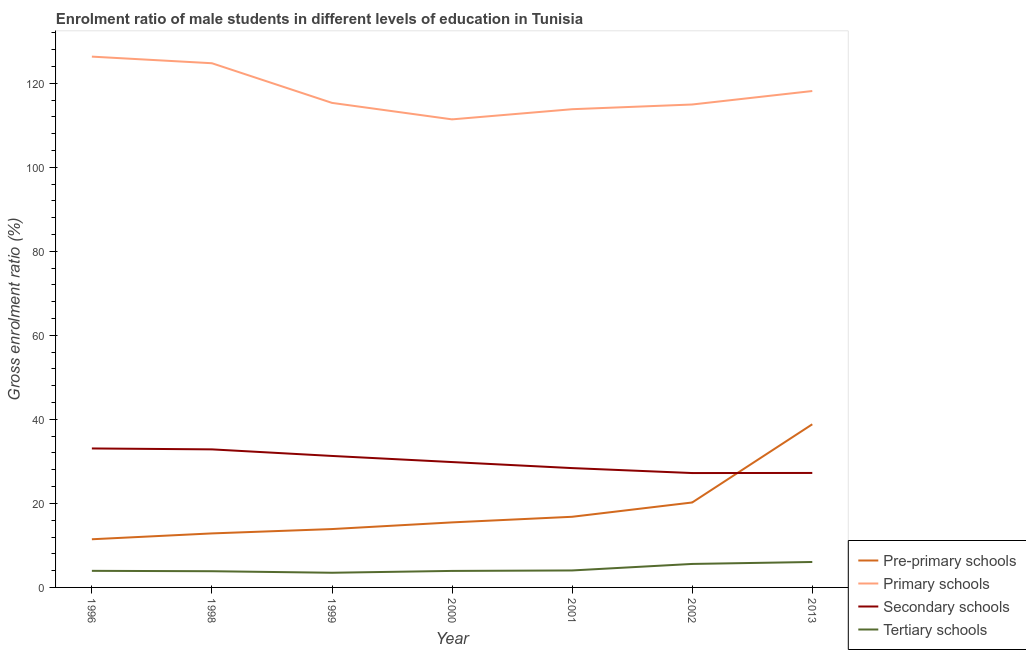How many different coloured lines are there?
Your response must be concise. 4. What is the gross enrolment ratio(female) in primary schools in 1996?
Ensure brevity in your answer.  126.34. Across all years, what is the maximum gross enrolment ratio(female) in secondary schools?
Offer a terse response. 33.08. Across all years, what is the minimum gross enrolment ratio(female) in primary schools?
Your answer should be very brief. 111.41. What is the total gross enrolment ratio(female) in secondary schools in the graph?
Your answer should be very brief. 209.96. What is the difference between the gross enrolment ratio(female) in pre-primary schools in 1996 and that in 1999?
Your response must be concise. -2.43. What is the difference between the gross enrolment ratio(female) in pre-primary schools in 2002 and the gross enrolment ratio(female) in tertiary schools in 1999?
Make the answer very short. 16.73. What is the average gross enrolment ratio(female) in tertiary schools per year?
Your answer should be very brief. 4.42. In the year 1999, what is the difference between the gross enrolment ratio(female) in primary schools and gross enrolment ratio(female) in secondary schools?
Give a very brief answer. 84.04. In how many years, is the gross enrolment ratio(female) in primary schools greater than 48 %?
Offer a terse response. 7. What is the ratio of the gross enrolment ratio(female) in primary schools in 2000 to that in 2002?
Provide a short and direct response. 0.97. Is the gross enrolment ratio(female) in pre-primary schools in 1999 less than that in 2000?
Make the answer very short. Yes. What is the difference between the highest and the second highest gross enrolment ratio(female) in pre-primary schools?
Your response must be concise. 18.61. What is the difference between the highest and the lowest gross enrolment ratio(female) in primary schools?
Ensure brevity in your answer.  14.93. In how many years, is the gross enrolment ratio(female) in primary schools greater than the average gross enrolment ratio(female) in primary schools taken over all years?
Give a very brief answer. 3. Is it the case that in every year, the sum of the gross enrolment ratio(female) in primary schools and gross enrolment ratio(female) in tertiary schools is greater than the sum of gross enrolment ratio(female) in secondary schools and gross enrolment ratio(female) in pre-primary schools?
Offer a terse response. Yes. Is it the case that in every year, the sum of the gross enrolment ratio(female) in pre-primary schools and gross enrolment ratio(female) in primary schools is greater than the gross enrolment ratio(female) in secondary schools?
Your answer should be compact. Yes. Is the gross enrolment ratio(female) in pre-primary schools strictly greater than the gross enrolment ratio(female) in secondary schools over the years?
Ensure brevity in your answer.  No. Where does the legend appear in the graph?
Make the answer very short. Bottom right. How are the legend labels stacked?
Give a very brief answer. Vertical. What is the title of the graph?
Provide a short and direct response. Enrolment ratio of male students in different levels of education in Tunisia. Does "United States" appear as one of the legend labels in the graph?
Make the answer very short. No. What is the label or title of the Y-axis?
Your answer should be compact. Gross enrolment ratio (%). What is the Gross enrolment ratio (%) of Pre-primary schools in 1996?
Provide a short and direct response. 11.47. What is the Gross enrolment ratio (%) of Primary schools in 1996?
Keep it short and to the point. 126.34. What is the Gross enrolment ratio (%) in Secondary schools in 1996?
Ensure brevity in your answer.  33.08. What is the Gross enrolment ratio (%) of Tertiary schools in 1996?
Your answer should be compact. 3.95. What is the Gross enrolment ratio (%) in Pre-primary schools in 1998?
Offer a terse response. 12.86. What is the Gross enrolment ratio (%) of Primary schools in 1998?
Make the answer very short. 124.77. What is the Gross enrolment ratio (%) of Secondary schools in 1998?
Your answer should be very brief. 32.86. What is the Gross enrolment ratio (%) in Tertiary schools in 1998?
Provide a short and direct response. 3.86. What is the Gross enrolment ratio (%) in Pre-primary schools in 1999?
Make the answer very short. 13.89. What is the Gross enrolment ratio (%) in Primary schools in 1999?
Give a very brief answer. 115.33. What is the Gross enrolment ratio (%) of Secondary schools in 1999?
Make the answer very short. 31.3. What is the Gross enrolment ratio (%) in Tertiary schools in 1999?
Your answer should be compact. 3.49. What is the Gross enrolment ratio (%) of Pre-primary schools in 2000?
Your answer should be compact. 15.48. What is the Gross enrolment ratio (%) of Primary schools in 2000?
Provide a succinct answer. 111.41. What is the Gross enrolment ratio (%) in Secondary schools in 2000?
Your answer should be compact. 29.84. What is the Gross enrolment ratio (%) of Tertiary schools in 2000?
Your answer should be compact. 3.93. What is the Gross enrolment ratio (%) in Pre-primary schools in 2001?
Make the answer very short. 16.82. What is the Gross enrolment ratio (%) of Primary schools in 2001?
Give a very brief answer. 113.83. What is the Gross enrolment ratio (%) of Secondary schools in 2001?
Give a very brief answer. 28.4. What is the Gross enrolment ratio (%) in Tertiary schools in 2001?
Your response must be concise. 4.04. What is the Gross enrolment ratio (%) in Pre-primary schools in 2002?
Give a very brief answer. 20.22. What is the Gross enrolment ratio (%) of Primary schools in 2002?
Offer a terse response. 114.95. What is the Gross enrolment ratio (%) of Secondary schools in 2002?
Offer a terse response. 27.23. What is the Gross enrolment ratio (%) in Tertiary schools in 2002?
Offer a terse response. 5.59. What is the Gross enrolment ratio (%) in Pre-primary schools in 2013?
Keep it short and to the point. 38.83. What is the Gross enrolment ratio (%) in Primary schools in 2013?
Provide a short and direct response. 118.16. What is the Gross enrolment ratio (%) in Secondary schools in 2013?
Provide a short and direct response. 27.25. What is the Gross enrolment ratio (%) in Tertiary schools in 2013?
Your answer should be compact. 6.06. Across all years, what is the maximum Gross enrolment ratio (%) in Pre-primary schools?
Give a very brief answer. 38.83. Across all years, what is the maximum Gross enrolment ratio (%) of Primary schools?
Your answer should be very brief. 126.34. Across all years, what is the maximum Gross enrolment ratio (%) of Secondary schools?
Your answer should be very brief. 33.08. Across all years, what is the maximum Gross enrolment ratio (%) in Tertiary schools?
Make the answer very short. 6.06. Across all years, what is the minimum Gross enrolment ratio (%) in Pre-primary schools?
Your answer should be very brief. 11.47. Across all years, what is the minimum Gross enrolment ratio (%) in Primary schools?
Provide a succinct answer. 111.41. Across all years, what is the minimum Gross enrolment ratio (%) of Secondary schools?
Your answer should be very brief. 27.23. Across all years, what is the minimum Gross enrolment ratio (%) in Tertiary schools?
Ensure brevity in your answer.  3.49. What is the total Gross enrolment ratio (%) of Pre-primary schools in the graph?
Keep it short and to the point. 129.57. What is the total Gross enrolment ratio (%) of Primary schools in the graph?
Your response must be concise. 824.8. What is the total Gross enrolment ratio (%) in Secondary schools in the graph?
Your answer should be very brief. 209.96. What is the total Gross enrolment ratio (%) in Tertiary schools in the graph?
Offer a very short reply. 30.92. What is the difference between the Gross enrolment ratio (%) of Pre-primary schools in 1996 and that in 1998?
Give a very brief answer. -1.39. What is the difference between the Gross enrolment ratio (%) of Primary schools in 1996 and that in 1998?
Provide a succinct answer. 1.57. What is the difference between the Gross enrolment ratio (%) of Secondary schools in 1996 and that in 1998?
Ensure brevity in your answer.  0.22. What is the difference between the Gross enrolment ratio (%) in Tertiary schools in 1996 and that in 1998?
Ensure brevity in your answer.  0.09. What is the difference between the Gross enrolment ratio (%) of Pre-primary schools in 1996 and that in 1999?
Provide a short and direct response. -2.43. What is the difference between the Gross enrolment ratio (%) of Primary schools in 1996 and that in 1999?
Your answer should be very brief. 11.01. What is the difference between the Gross enrolment ratio (%) in Secondary schools in 1996 and that in 1999?
Give a very brief answer. 1.78. What is the difference between the Gross enrolment ratio (%) in Tertiary schools in 1996 and that in 1999?
Offer a very short reply. 0.45. What is the difference between the Gross enrolment ratio (%) of Pre-primary schools in 1996 and that in 2000?
Keep it short and to the point. -4.02. What is the difference between the Gross enrolment ratio (%) of Primary schools in 1996 and that in 2000?
Provide a succinct answer. 14.93. What is the difference between the Gross enrolment ratio (%) in Secondary schools in 1996 and that in 2000?
Your answer should be very brief. 3.24. What is the difference between the Gross enrolment ratio (%) of Tertiary schools in 1996 and that in 2000?
Ensure brevity in your answer.  0.02. What is the difference between the Gross enrolment ratio (%) of Pre-primary schools in 1996 and that in 2001?
Offer a terse response. -5.35. What is the difference between the Gross enrolment ratio (%) in Primary schools in 1996 and that in 2001?
Ensure brevity in your answer.  12.51. What is the difference between the Gross enrolment ratio (%) in Secondary schools in 1996 and that in 2001?
Keep it short and to the point. 4.68. What is the difference between the Gross enrolment ratio (%) of Tertiary schools in 1996 and that in 2001?
Offer a very short reply. -0.09. What is the difference between the Gross enrolment ratio (%) in Pre-primary schools in 1996 and that in 2002?
Your answer should be compact. -8.76. What is the difference between the Gross enrolment ratio (%) in Primary schools in 1996 and that in 2002?
Offer a very short reply. 11.39. What is the difference between the Gross enrolment ratio (%) of Secondary schools in 1996 and that in 2002?
Keep it short and to the point. 5.86. What is the difference between the Gross enrolment ratio (%) of Tertiary schools in 1996 and that in 2002?
Offer a very short reply. -1.65. What is the difference between the Gross enrolment ratio (%) of Pre-primary schools in 1996 and that in 2013?
Your answer should be compact. -27.37. What is the difference between the Gross enrolment ratio (%) in Primary schools in 1996 and that in 2013?
Your answer should be very brief. 8.19. What is the difference between the Gross enrolment ratio (%) of Secondary schools in 1996 and that in 2013?
Offer a very short reply. 5.83. What is the difference between the Gross enrolment ratio (%) in Tertiary schools in 1996 and that in 2013?
Make the answer very short. -2.11. What is the difference between the Gross enrolment ratio (%) in Pre-primary schools in 1998 and that in 1999?
Provide a short and direct response. -1.03. What is the difference between the Gross enrolment ratio (%) of Primary schools in 1998 and that in 1999?
Offer a terse response. 9.44. What is the difference between the Gross enrolment ratio (%) in Secondary schools in 1998 and that in 1999?
Give a very brief answer. 1.57. What is the difference between the Gross enrolment ratio (%) in Tertiary schools in 1998 and that in 1999?
Make the answer very short. 0.37. What is the difference between the Gross enrolment ratio (%) of Pre-primary schools in 1998 and that in 2000?
Make the answer very short. -2.62. What is the difference between the Gross enrolment ratio (%) of Primary schools in 1998 and that in 2000?
Provide a succinct answer. 13.36. What is the difference between the Gross enrolment ratio (%) of Secondary schools in 1998 and that in 2000?
Your answer should be very brief. 3.02. What is the difference between the Gross enrolment ratio (%) in Tertiary schools in 1998 and that in 2000?
Ensure brevity in your answer.  -0.07. What is the difference between the Gross enrolment ratio (%) of Pre-primary schools in 1998 and that in 2001?
Offer a very short reply. -3.96. What is the difference between the Gross enrolment ratio (%) of Primary schools in 1998 and that in 2001?
Your response must be concise. 10.94. What is the difference between the Gross enrolment ratio (%) in Secondary schools in 1998 and that in 2001?
Ensure brevity in your answer.  4.46. What is the difference between the Gross enrolment ratio (%) in Tertiary schools in 1998 and that in 2001?
Ensure brevity in your answer.  -0.18. What is the difference between the Gross enrolment ratio (%) in Pre-primary schools in 1998 and that in 2002?
Offer a very short reply. -7.36. What is the difference between the Gross enrolment ratio (%) of Primary schools in 1998 and that in 2002?
Provide a short and direct response. 9.82. What is the difference between the Gross enrolment ratio (%) in Secondary schools in 1998 and that in 2002?
Offer a terse response. 5.64. What is the difference between the Gross enrolment ratio (%) of Tertiary schools in 1998 and that in 2002?
Offer a very short reply. -1.73. What is the difference between the Gross enrolment ratio (%) in Pre-primary schools in 1998 and that in 2013?
Offer a very short reply. -25.98. What is the difference between the Gross enrolment ratio (%) in Primary schools in 1998 and that in 2013?
Make the answer very short. 6.61. What is the difference between the Gross enrolment ratio (%) in Secondary schools in 1998 and that in 2013?
Keep it short and to the point. 5.61. What is the difference between the Gross enrolment ratio (%) of Tertiary schools in 1998 and that in 2013?
Give a very brief answer. -2.2. What is the difference between the Gross enrolment ratio (%) in Pre-primary schools in 1999 and that in 2000?
Your answer should be compact. -1.59. What is the difference between the Gross enrolment ratio (%) in Primary schools in 1999 and that in 2000?
Provide a short and direct response. 3.92. What is the difference between the Gross enrolment ratio (%) in Secondary schools in 1999 and that in 2000?
Provide a succinct answer. 1.46. What is the difference between the Gross enrolment ratio (%) of Tertiary schools in 1999 and that in 2000?
Provide a succinct answer. -0.44. What is the difference between the Gross enrolment ratio (%) in Pre-primary schools in 1999 and that in 2001?
Offer a very short reply. -2.92. What is the difference between the Gross enrolment ratio (%) of Primary schools in 1999 and that in 2001?
Give a very brief answer. 1.5. What is the difference between the Gross enrolment ratio (%) of Secondary schools in 1999 and that in 2001?
Provide a succinct answer. 2.89. What is the difference between the Gross enrolment ratio (%) of Tertiary schools in 1999 and that in 2001?
Keep it short and to the point. -0.55. What is the difference between the Gross enrolment ratio (%) of Pre-primary schools in 1999 and that in 2002?
Ensure brevity in your answer.  -6.33. What is the difference between the Gross enrolment ratio (%) of Primary schools in 1999 and that in 2002?
Your response must be concise. 0.38. What is the difference between the Gross enrolment ratio (%) of Secondary schools in 1999 and that in 2002?
Give a very brief answer. 4.07. What is the difference between the Gross enrolment ratio (%) of Tertiary schools in 1999 and that in 2002?
Your answer should be very brief. -2.1. What is the difference between the Gross enrolment ratio (%) of Pre-primary schools in 1999 and that in 2013?
Make the answer very short. -24.94. What is the difference between the Gross enrolment ratio (%) in Primary schools in 1999 and that in 2013?
Make the answer very short. -2.83. What is the difference between the Gross enrolment ratio (%) in Secondary schools in 1999 and that in 2013?
Your response must be concise. 4.05. What is the difference between the Gross enrolment ratio (%) of Tertiary schools in 1999 and that in 2013?
Provide a short and direct response. -2.57. What is the difference between the Gross enrolment ratio (%) of Pre-primary schools in 2000 and that in 2001?
Make the answer very short. -1.33. What is the difference between the Gross enrolment ratio (%) of Primary schools in 2000 and that in 2001?
Make the answer very short. -2.42. What is the difference between the Gross enrolment ratio (%) of Secondary schools in 2000 and that in 2001?
Offer a terse response. 1.43. What is the difference between the Gross enrolment ratio (%) of Tertiary schools in 2000 and that in 2001?
Keep it short and to the point. -0.11. What is the difference between the Gross enrolment ratio (%) in Pre-primary schools in 2000 and that in 2002?
Ensure brevity in your answer.  -4.74. What is the difference between the Gross enrolment ratio (%) in Primary schools in 2000 and that in 2002?
Ensure brevity in your answer.  -3.54. What is the difference between the Gross enrolment ratio (%) in Secondary schools in 2000 and that in 2002?
Your response must be concise. 2.61. What is the difference between the Gross enrolment ratio (%) of Tertiary schools in 2000 and that in 2002?
Provide a short and direct response. -1.66. What is the difference between the Gross enrolment ratio (%) in Pre-primary schools in 2000 and that in 2013?
Your response must be concise. -23.35. What is the difference between the Gross enrolment ratio (%) in Primary schools in 2000 and that in 2013?
Provide a succinct answer. -6.75. What is the difference between the Gross enrolment ratio (%) of Secondary schools in 2000 and that in 2013?
Give a very brief answer. 2.59. What is the difference between the Gross enrolment ratio (%) in Tertiary schools in 2000 and that in 2013?
Your answer should be compact. -2.13. What is the difference between the Gross enrolment ratio (%) in Pre-primary schools in 2001 and that in 2002?
Your answer should be compact. -3.41. What is the difference between the Gross enrolment ratio (%) in Primary schools in 2001 and that in 2002?
Your answer should be very brief. -1.12. What is the difference between the Gross enrolment ratio (%) in Secondary schools in 2001 and that in 2002?
Make the answer very short. 1.18. What is the difference between the Gross enrolment ratio (%) in Tertiary schools in 2001 and that in 2002?
Give a very brief answer. -1.55. What is the difference between the Gross enrolment ratio (%) in Pre-primary schools in 2001 and that in 2013?
Ensure brevity in your answer.  -22.02. What is the difference between the Gross enrolment ratio (%) of Primary schools in 2001 and that in 2013?
Your answer should be compact. -4.33. What is the difference between the Gross enrolment ratio (%) of Secondary schools in 2001 and that in 2013?
Provide a short and direct response. 1.16. What is the difference between the Gross enrolment ratio (%) of Tertiary schools in 2001 and that in 2013?
Your response must be concise. -2.02. What is the difference between the Gross enrolment ratio (%) in Pre-primary schools in 2002 and that in 2013?
Keep it short and to the point. -18.61. What is the difference between the Gross enrolment ratio (%) in Primary schools in 2002 and that in 2013?
Ensure brevity in your answer.  -3.21. What is the difference between the Gross enrolment ratio (%) in Secondary schools in 2002 and that in 2013?
Make the answer very short. -0.02. What is the difference between the Gross enrolment ratio (%) of Tertiary schools in 2002 and that in 2013?
Offer a very short reply. -0.47. What is the difference between the Gross enrolment ratio (%) in Pre-primary schools in 1996 and the Gross enrolment ratio (%) in Primary schools in 1998?
Provide a short and direct response. -113.31. What is the difference between the Gross enrolment ratio (%) of Pre-primary schools in 1996 and the Gross enrolment ratio (%) of Secondary schools in 1998?
Keep it short and to the point. -21.4. What is the difference between the Gross enrolment ratio (%) in Pre-primary schools in 1996 and the Gross enrolment ratio (%) in Tertiary schools in 1998?
Offer a terse response. 7.61. What is the difference between the Gross enrolment ratio (%) in Primary schools in 1996 and the Gross enrolment ratio (%) in Secondary schools in 1998?
Keep it short and to the point. 93.48. What is the difference between the Gross enrolment ratio (%) of Primary schools in 1996 and the Gross enrolment ratio (%) of Tertiary schools in 1998?
Your answer should be very brief. 122.49. What is the difference between the Gross enrolment ratio (%) in Secondary schools in 1996 and the Gross enrolment ratio (%) in Tertiary schools in 1998?
Keep it short and to the point. 29.22. What is the difference between the Gross enrolment ratio (%) in Pre-primary schools in 1996 and the Gross enrolment ratio (%) in Primary schools in 1999?
Make the answer very short. -103.87. What is the difference between the Gross enrolment ratio (%) in Pre-primary schools in 1996 and the Gross enrolment ratio (%) in Secondary schools in 1999?
Provide a succinct answer. -19.83. What is the difference between the Gross enrolment ratio (%) in Pre-primary schools in 1996 and the Gross enrolment ratio (%) in Tertiary schools in 1999?
Offer a terse response. 7.97. What is the difference between the Gross enrolment ratio (%) of Primary schools in 1996 and the Gross enrolment ratio (%) of Secondary schools in 1999?
Your answer should be compact. 95.05. What is the difference between the Gross enrolment ratio (%) of Primary schools in 1996 and the Gross enrolment ratio (%) of Tertiary schools in 1999?
Your answer should be very brief. 122.85. What is the difference between the Gross enrolment ratio (%) of Secondary schools in 1996 and the Gross enrolment ratio (%) of Tertiary schools in 1999?
Your answer should be compact. 29.59. What is the difference between the Gross enrolment ratio (%) in Pre-primary schools in 1996 and the Gross enrolment ratio (%) in Primary schools in 2000?
Your answer should be very brief. -99.95. What is the difference between the Gross enrolment ratio (%) of Pre-primary schools in 1996 and the Gross enrolment ratio (%) of Secondary schools in 2000?
Provide a short and direct response. -18.37. What is the difference between the Gross enrolment ratio (%) in Pre-primary schools in 1996 and the Gross enrolment ratio (%) in Tertiary schools in 2000?
Ensure brevity in your answer.  7.54. What is the difference between the Gross enrolment ratio (%) in Primary schools in 1996 and the Gross enrolment ratio (%) in Secondary schools in 2000?
Your answer should be very brief. 96.51. What is the difference between the Gross enrolment ratio (%) of Primary schools in 1996 and the Gross enrolment ratio (%) of Tertiary schools in 2000?
Provide a succinct answer. 122.41. What is the difference between the Gross enrolment ratio (%) in Secondary schools in 1996 and the Gross enrolment ratio (%) in Tertiary schools in 2000?
Offer a terse response. 29.15. What is the difference between the Gross enrolment ratio (%) of Pre-primary schools in 1996 and the Gross enrolment ratio (%) of Primary schools in 2001?
Give a very brief answer. -102.36. What is the difference between the Gross enrolment ratio (%) of Pre-primary schools in 1996 and the Gross enrolment ratio (%) of Secondary schools in 2001?
Give a very brief answer. -16.94. What is the difference between the Gross enrolment ratio (%) of Pre-primary schools in 1996 and the Gross enrolment ratio (%) of Tertiary schools in 2001?
Keep it short and to the point. 7.42. What is the difference between the Gross enrolment ratio (%) of Primary schools in 1996 and the Gross enrolment ratio (%) of Secondary schools in 2001?
Provide a succinct answer. 97.94. What is the difference between the Gross enrolment ratio (%) of Primary schools in 1996 and the Gross enrolment ratio (%) of Tertiary schools in 2001?
Give a very brief answer. 122.3. What is the difference between the Gross enrolment ratio (%) of Secondary schools in 1996 and the Gross enrolment ratio (%) of Tertiary schools in 2001?
Offer a very short reply. 29.04. What is the difference between the Gross enrolment ratio (%) of Pre-primary schools in 1996 and the Gross enrolment ratio (%) of Primary schools in 2002?
Your response must be concise. -103.49. What is the difference between the Gross enrolment ratio (%) of Pre-primary schools in 1996 and the Gross enrolment ratio (%) of Secondary schools in 2002?
Keep it short and to the point. -15.76. What is the difference between the Gross enrolment ratio (%) of Pre-primary schools in 1996 and the Gross enrolment ratio (%) of Tertiary schools in 2002?
Offer a terse response. 5.87. What is the difference between the Gross enrolment ratio (%) of Primary schools in 1996 and the Gross enrolment ratio (%) of Secondary schools in 2002?
Provide a short and direct response. 99.12. What is the difference between the Gross enrolment ratio (%) of Primary schools in 1996 and the Gross enrolment ratio (%) of Tertiary schools in 2002?
Offer a very short reply. 120.75. What is the difference between the Gross enrolment ratio (%) in Secondary schools in 1996 and the Gross enrolment ratio (%) in Tertiary schools in 2002?
Offer a terse response. 27.49. What is the difference between the Gross enrolment ratio (%) in Pre-primary schools in 1996 and the Gross enrolment ratio (%) in Primary schools in 2013?
Offer a very short reply. -106.69. What is the difference between the Gross enrolment ratio (%) in Pre-primary schools in 1996 and the Gross enrolment ratio (%) in Secondary schools in 2013?
Keep it short and to the point. -15.78. What is the difference between the Gross enrolment ratio (%) in Pre-primary schools in 1996 and the Gross enrolment ratio (%) in Tertiary schools in 2013?
Provide a short and direct response. 5.41. What is the difference between the Gross enrolment ratio (%) in Primary schools in 1996 and the Gross enrolment ratio (%) in Secondary schools in 2013?
Keep it short and to the point. 99.1. What is the difference between the Gross enrolment ratio (%) in Primary schools in 1996 and the Gross enrolment ratio (%) in Tertiary schools in 2013?
Provide a succinct answer. 120.29. What is the difference between the Gross enrolment ratio (%) of Secondary schools in 1996 and the Gross enrolment ratio (%) of Tertiary schools in 2013?
Give a very brief answer. 27.02. What is the difference between the Gross enrolment ratio (%) in Pre-primary schools in 1998 and the Gross enrolment ratio (%) in Primary schools in 1999?
Provide a short and direct response. -102.47. What is the difference between the Gross enrolment ratio (%) in Pre-primary schools in 1998 and the Gross enrolment ratio (%) in Secondary schools in 1999?
Ensure brevity in your answer.  -18.44. What is the difference between the Gross enrolment ratio (%) in Pre-primary schools in 1998 and the Gross enrolment ratio (%) in Tertiary schools in 1999?
Ensure brevity in your answer.  9.37. What is the difference between the Gross enrolment ratio (%) in Primary schools in 1998 and the Gross enrolment ratio (%) in Secondary schools in 1999?
Ensure brevity in your answer.  93.48. What is the difference between the Gross enrolment ratio (%) in Primary schools in 1998 and the Gross enrolment ratio (%) in Tertiary schools in 1999?
Give a very brief answer. 121.28. What is the difference between the Gross enrolment ratio (%) of Secondary schools in 1998 and the Gross enrolment ratio (%) of Tertiary schools in 1999?
Keep it short and to the point. 29.37. What is the difference between the Gross enrolment ratio (%) of Pre-primary schools in 1998 and the Gross enrolment ratio (%) of Primary schools in 2000?
Give a very brief answer. -98.55. What is the difference between the Gross enrolment ratio (%) of Pre-primary schools in 1998 and the Gross enrolment ratio (%) of Secondary schools in 2000?
Your answer should be compact. -16.98. What is the difference between the Gross enrolment ratio (%) of Pre-primary schools in 1998 and the Gross enrolment ratio (%) of Tertiary schools in 2000?
Your answer should be very brief. 8.93. What is the difference between the Gross enrolment ratio (%) in Primary schools in 1998 and the Gross enrolment ratio (%) in Secondary schools in 2000?
Ensure brevity in your answer.  94.93. What is the difference between the Gross enrolment ratio (%) in Primary schools in 1998 and the Gross enrolment ratio (%) in Tertiary schools in 2000?
Your answer should be compact. 120.84. What is the difference between the Gross enrolment ratio (%) of Secondary schools in 1998 and the Gross enrolment ratio (%) of Tertiary schools in 2000?
Keep it short and to the point. 28.93. What is the difference between the Gross enrolment ratio (%) in Pre-primary schools in 1998 and the Gross enrolment ratio (%) in Primary schools in 2001?
Offer a terse response. -100.97. What is the difference between the Gross enrolment ratio (%) of Pre-primary schools in 1998 and the Gross enrolment ratio (%) of Secondary schools in 2001?
Provide a short and direct response. -15.55. What is the difference between the Gross enrolment ratio (%) in Pre-primary schools in 1998 and the Gross enrolment ratio (%) in Tertiary schools in 2001?
Make the answer very short. 8.82. What is the difference between the Gross enrolment ratio (%) in Primary schools in 1998 and the Gross enrolment ratio (%) in Secondary schools in 2001?
Give a very brief answer. 96.37. What is the difference between the Gross enrolment ratio (%) of Primary schools in 1998 and the Gross enrolment ratio (%) of Tertiary schools in 2001?
Make the answer very short. 120.73. What is the difference between the Gross enrolment ratio (%) in Secondary schools in 1998 and the Gross enrolment ratio (%) in Tertiary schools in 2001?
Offer a very short reply. 28.82. What is the difference between the Gross enrolment ratio (%) of Pre-primary schools in 1998 and the Gross enrolment ratio (%) of Primary schools in 2002?
Your answer should be very brief. -102.09. What is the difference between the Gross enrolment ratio (%) of Pre-primary schools in 1998 and the Gross enrolment ratio (%) of Secondary schools in 2002?
Make the answer very short. -14.37. What is the difference between the Gross enrolment ratio (%) in Pre-primary schools in 1998 and the Gross enrolment ratio (%) in Tertiary schools in 2002?
Make the answer very short. 7.27. What is the difference between the Gross enrolment ratio (%) in Primary schools in 1998 and the Gross enrolment ratio (%) in Secondary schools in 2002?
Offer a terse response. 97.55. What is the difference between the Gross enrolment ratio (%) in Primary schools in 1998 and the Gross enrolment ratio (%) in Tertiary schools in 2002?
Provide a succinct answer. 119.18. What is the difference between the Gross enrolment ratio (%) in Secondary schools in 1998 and the Gross enrolment ratio (%) in Tertiary schools in 2002?
Your response must be concise. 27.27. What is the difference between the Gross enrolment ratio (%) of Pre-primary schools in 1998 and the Gross enrolment ratio (%) of Primary schools in 2013?
Provide a short and direct response. -105.3. What is the difference between the Gross enrolment ratio (%) of Pre-primary schools in 1998 and the Gross enrolment ratio (%) of Secondary schools in 2013?
Provide a short and direct response. -14.39. What is the difference between the Gross enrolment ratio (%) of Pre-primary schools in 1998 and the Gross enrolment ratio (%) of Tertiary schools in 2013?
Offer a very short reply. 6.8. What is the difference between the Gross enrolment ratio (%) of Primary schools in 1998 and the Gross enrolment ratio (%) of Secondary schools in 2013?
Your answer should be compact. 97.52. What is the difference between the Gross enrolment ratio (%) in Primary schools in 1998 and the Gross enrolment ratio (%) in Tertiary schools in 2013?
Your response must be concise. 118.71. What is the difference between the Gross enrolment ratio (%) of Secondary schools in 1998 and the Gross enrolment ratio (%) of Tertiary schools in 2013?
Ensure brevity in your answer.  26.8. What is the difference between the Gross enrolment ratio (%) of Pre-primary schools in 1999 and the Gross enrolment ratio (%) of Primary schools in 2000?
Provide a short and direct response. -97.52. What is the difference between the Gross enrolment ratio (%) in Pre-primary schools in 1999 and the Gross enrolment ratio (%) in Secondary schools in 2000?
Provide a succinct answer. -15.95. What is the difference between the Gross enrolment ratio (%) in Pre-primary schools in 1999 and the Gross enrolment ratio (%) in Tertiary schools in 2000?
Offer a terse response. 9.96. What is the difference between the Gross enrolment ratio (%) in Primary schools in 1999 and the Gross enrolment ratio (%) in Secondary schools in 2000?
Keep it short and to the point. 85.49. What is the difference between the Gross enrolment ratio (%) in Primary schools in 1999 and the Gross enrolment ratio (%) in Tertiary schools in 2000?
Offer a very short reply. 111.4. What is the difference between the Gross enrolment ratio (%) in Secondary schools in 1999 and the Gross enrolment ratio (%) in Tertiary schools in 2000?
Ensure brevity in your answer.  27.37. What is the difference between the Gross enrolment ratio (%) in Pre-primary schools in 1999 and the Gross enrolment ratio (%) in Primary schools in 2001?
Ensure brevity in your answer.  -99.94. What is the difference between the Gross enrolment ratio (%) of Pre-primary schools in 1999 and the Gross enrolment ratio (%) of Secondary schools in 2001?
Ensure brevity in your answer.  -14.51. What is the difference between the Gross enrolment ratio (%) in Pre-primary schools in 1999 and the Gross enrolment ratio (%) in Tertiary schools in 2001?
Your answer should be very brief. 9.85. What is the difference between the Gross enrolment ratio (%) of Primary schools in 1999 and the Gross enrolment ratio (%) of Secondary schools in 2001?
Ensure brevity in your answer.  86.93. What is the difference between the Gross enrolment ratio (%) of Primary schools in 1999 and the Gross enrolment ratio (%) of Tertiary schools in 2001?
Provide a short and direct response. 111.29. What is the difference between the Gross enrolment ratio (%) in Secondary schools in 1999 and the Gross enrolment ratio (%) in Tertiary schools in 2001?
Keep it short and to the point. 27.26. What is the difference between the Gross enrolment ratio (%) in Pre-primary schools in 1999 and the Gross enrolment ratio (%) in Primary schools in 2002?
Keep it short and to the point. -101.06. What is the difference between the Gross enrolment ratio (%) in Pre-primary schools in 1999 and the Gross enrolment ratio (%) in Secondary schools in 2002?
Offer a terse response. -13.33. What is the difference between the Gross enrolment ratio (%) of Pre-primary schools in 1999 and the Gross enrolment ratio (%) of Tertiary schools in 2002?
Your answer should be very brief. 8.3. What is the difference between the Gross enrolment ratio (%) of Primary schools in 1999 and the Gross enrolment ratio (%) of Secondary schools in 2002?
Make the answer very short. 88.11. What is the difference between the Gross enrolment ratio (%) in Primary schools in 1999 and the Gross enrolment ratio (%) in Tertiary schools in 2002?
Provide a succinct answer. 109.74. What is the difference between the Gross enrolment ratio (%) of Secondary schools in 1999 and the Gross enrolment ratio (%) of Tertiary schools in 2002?
Provide a short and direct response. 25.7. What is the difference between the Gross enrolment ratio (%) in Pre-primary schools in 1999 and the Gross enrolment ratio (%) in Primary schools in 2013?
Give a very brief answer. -104.27. What is the difference between the Gross enrolment ratio (%) of Pre-primary schools in 1999 and the Gross enrolment ratio (%) of Secondary schools in 2013?
Provide a short and direct response. -13.36. What is the difference between the Gross enrolment ratio (%) of Pre-primary schools in 1999 and the Gross enrolment ratio (%) of Tertiary schools in 2013?
Your response must be concise. 7.84. What is the difference between the Gross enrolment ratio (%) of Primary schools in 1999 and the Gross enrolment ratio (%) of Secondary schools in 2013?
Keep it short and to the point. 88.08. What is the difference between the Gross enrolment ratio (%) in Primary schools in 1999 and the Gross enrolment ratio (%) in Tertiary schools in 2013?
Offer a terse response. 109.28. What is the difference between the Gross enrolment ratio (%) of Secondary schools in 1999 and the Gross enrolment ratio (%) of Tertiary schools in 2013?
Offer a very short reply. 25.24. What is the difference between the Gross enrolment ratio (%) of Pre-primary schools in 2000 and the Gross enrolment ratio (%) of Primary schools in 2001?
Your answer should be very brief. -98.35. What is the difference between the Gross enrolment ratio (%) in Pre-primary schools in 2000 and the Gross enrolment ratio (%) in Secondary schools in 2001?
Offer a terse response. -12.92. What is the difference between the Gross enrolment ratio (%) of Pre-primary schools in 2000 and the Gross enrolment ratio (%) of Tertiary schools in 2001?
Offer a very short reply. 11.44. What is the difference between the Gross enrolment ratio (%) of Primary schools in 2000 and the Gross enrolment ratio (%) of Secondary schools in 2001?
Ensure brevity in your answer.  83.01. What is the difference between the Gross enrolment ratio (%) of Primary schools in 2000 and the Gross enrolment ratio (%) of Tertiary schools in 2001?
Provide a succinct answer. 107.37. What is the difference between the Gross enrolment ratio (%) of Secondary schools in 2000 and the Gross enrolment ratio (%) of Tertiary schools in 2001?
Your response must be concise. 25.8. What is the difference between the Gross enrolment ratio (%) in Pre-primary schools in 2000 and the Gross enrolment ratio (%) in Primary schools in 2002?
Make the answer very short. -99.47. What is the difference between the Gross enrolment ratio (%) of Pre-primary schools in 2000 and the Gross enrolment ratio (%) of Secondary schools in 2002?
Your answer should be compact. -11.74. What is the difference between the Gross enrolment ratio (%) in Pre-primary schools in 2000 and the Gross enrolment ratio (%) in Tertiary schools in 2002?
Give a very brief answer. 9.89. What is the difference between the Gross enrolment ratio (%) of Primary schools in 2000 and the Gross enrolment ratio (%) of Secondary schools in 2002?
Your response must be concise. 84.19. What is the difference between the Gross enrolment ratio (%) in Primary schools in 2000 and the Gross enrolment ratio (%) in Tertiary schools in 2002?
Your answer should be compact. 105.82. What is the difference between the Gross enrolment ratio (%) of Secondary schools in 2000 and the Gross enrolment ratio (%) of Tertiary schools in 2002?
Offer a very short reply. 24.25. What is the difference between the Gross enrolment ratio (%) of Pre-primary schools in 2000 and the Gross enrolment ratio (%) of Primary schools in 2013?
Ensure brevity in your answer.  -102.68. What is the difference between the Gross enrolment ratio (%) of Pre-primary schools in 2000 and the Gross enrolment ratio (%) of Secondary schools in 2013?
Provide a succinct answer. -11.77. What is the difference between the Gross enrolment ratio (%) of Pre-primary schools in 2000 and the Gross enrolment ratio (%) of Tertiary schools in 2013?
Offer a very short reply. 9.42. What is the difference between the Gross enrolment ratio (%) in Primary schools in 2000 and the Gross enrolment ratio (%) in Secondary schools in 2013?
Ensure brevity in your answer.  84.16. What is the difference between the Gross enrolment ratio (%) of Primary schools in 2000 and the Gross enrolment ratio (%) of Tertiary schools in 2013?
Ensure brevity in your answer.  105.35. What is the difference between the Gross enrolment ratio (%) in Secondary schools in 2000 and the Gross enrolment ratio (%) in Tertiary schools in 2013?
Give a very brief answer. 23.78. What is the difference between the Gross enrolment ratio (%) in Pre-primary schools in 2001 and the Gross enrolment ratio (%) in Primary schools in 2002?
Give a very brief answer. -98.14. What is the difference between the Gross enrolment ratio (%) in Pre-primary schools in 2001 and the Gross enrolment ratio (%) in Secondary schools in 2002?
Offer a very short reply. -10.41. What is the difference between the Gross enrolment ratio (%) of Pre-primary schools in 2001 and the Gross enrolment ratio (%) of Tertiary schools in 2002?
Ensure brevity in your answer.  11.22. What is the difference between the Gross enrolment ratio (%) of Primary schools in 2001 and the Gross enrolment ratio (%) of Secondary schools in 2002?
Make the answer very short. 86.6. What is the difference between the Gross enrolment ratio (%) of Primary schools in 2001 and the Gross enrolment ratio (%) of Tertiary schools in 2002?
Your answer should be very brief. 108.24. What is the difference between the Gross enrolment ratio (%) in Secondary schools in 2001 and the Gross enrolment ratio (%) in Tertiary schools in 2002?
Ensure brevity in your answer.  22.81. What is the difference between the Gross enrolment ratio (%) in Pre-primary schools in 2001 and the Gross enrolment ratio (%) in Primary schools in 2013?
Make the answer very short. -101.34. What is the difference between the Gross enrolment ratio (%) in Pre-primary schools in 2001 and the Gross enrolment ratio (%) in Secondary schools in 2013?
Provide a succinct answer. -10.43. What is the difference between the Gross enrolment ratio (%) in Pre-primary schools in 2001 and the Gross enrolment ratio (%) in Tertiary schools in 2013?
Offer a very short reply. 10.76. What is the difference between the Gross enrolment ratio (%) of Primary schools in 2001 and the Gross enrolment ratio (%) of Secondary schools in 2013?
Give a very brief answer. 86.58. What is the difference between the Gross enrolment ratio (%) in Primary schools in 2001 and the Gross enrolment ratio (%) in Tertiary schools in 2013?
Your answer should be compact. 107.77. What is the difference between the Gross enrolment ratio (%) in Secondary schools in 2001 and the Gross enrolment ratio (%) in Tertiary schools in 2013?
Give a very brief answer. 22.35. What is the difference between the Gross enrolment ratio (%) of Pre-primary schools in 2002 and the Gross enrolment ratio (%) of Primary schools in 2013?
Ensure brevity in your answer.  -97.94. What is the difference between the Gross enrolment ratio (%) in Pre-primary schools in 2002 and the Gross enrolment ratio (%) in Secondary schools in 2013?
Provide a short and direct response. -7.03. What is the difference between the Gross enrolment ratio (%) in Pre-primary schools in 2002 and the Gross enrolment ratio (%) in Tertiary schools in 2013?
Keep it short and to the point. 14.16. What is the difference between the Gross enrolment ratio (%) in Primary schools in 2002 and the Gross enrolment ratio (%) in Secondary schools in 2013?
Make the answer very short. 87.7. What is the difference between the Gross enrolment ratio (%) in Primary schools in 2002 and the Gross enrolment ratio (%) in Tertiary schools in 2013?
Your response must be concise. 108.89. What is the difference between the Gross enrolment ratio (%) of Secondary schools in 2002 and the Gross enrolment ratio (%) of Tertiary schools in 2013?
Keep it short and to the point. 21.17. What is the average Gross enrolment ratio (%) in Pre-primary schools per year?
Make the answer very short. 18.51. What is the average Gross enrolment ratio (%) of Primary schools per year?
Provide a succinct answer. 117.83. What is the average Gross enrolment ratio (%) in Secondary schools per year?
Provide a succinct answer. 29.99. What is the average Gross enrolment ratio (%) in Tertiary schools per year?
Ensure brevity in your answer.  4.42. In the year 1996, what is the difference between the Gross enrolment ratio (%) in Pre-primary schools and Gross enrolment ratio (%) in Primary schools?
Offer a terse response. -114.88. In the year 1996, what is the difference between the Gross enrolment ratio (%) in Pre-primary schools and Gross enrolment ratio (%) in Secondary schools?
Offer a terse response. -21.61. In the year 1996, what is the difference between the Gross enrolment ratio (%) of Pre-primary schools and Gross enrolment ratio (%) of Tertiary schools?
Provide a succinct answer. 7.52. In the year 1996, what is the difference between the Gross enrolment ratio (%) in Primary schools and Gross enrolment ratio (%) in Secondary schools?
Keep it short and to the point. 93.26. In the year 1996, what is the difference between the Gross enrolment ratio (%) in Primary schools and Gross enrolment ratio (%) in Tertiary schools?
Make the answer very short. 122.4. In the year 1996, what is the difference between the Gross enrolment ratio (%) of Secondary schools and Gross enrolment ratio (%) of Tertiary schools?
Ensure brevity in your answer.  29.13. In the year 1998, what is the difference between the Gross enrolment ratio (%) in Pre-primary schools and Gross enrolment ratio (%) in Primary schools?
Offer a terse response. -111.91. In the year 1998, what is the difference between the Gross enrolment ratio (%) in Pre-primary schools and Gross enrolment ratio (%) in Secondary schools?
Offer a terse response. -20. In the year 1998, what is the difference between the Gross enrolment ratio (%) in Pre-primary schools and Gross enrolment ratio (%) in Tertiary schools?
Offer a very short reply. 9. In the year 1998, what is the difference between the Gross enrolment ratio (%) of Primary schools and Gross enrolment ratio (%) of Secondary schools?
Offer a very short reply. 91.91. In the year 1998, what is the difference between the Gross enrolment ratio (%) in Primary schools and Gross enrolment ratio (%) in Tertiary schools?
Ensure brevity in your answer.  120.91. In the year 1998, what is the difference between the Gross enrolment ratio (%) of Secondary schools and Gross enrolment ratio (%) of Tertiary schools?
Ensure brevity in your answer.  29. In the year 1999, what is the difference between the Gross enrolment ratio (%) in Pre-primary schools and Gross enrolment ratio (%) in Primary schools?
Your response must be concise. -101.44. In the year 1999, what is the difference between the Gross enrolment ratio (%) of Pre-primary schools and Gross enrolment ratio (%) of Secondary schools?
Provide a succinct answer. -17.4. In the year 1999, what is the difference between the Gross enrolment ratio (%) in Pre-primary schools and Gross enrolment ratio (%) in Tertiary schools?
Offer a very short reply. 10.4. In the year 1999, what is the difference between the Gross enrolment ratio (%) of Primary schools and Gross enrolment ratio (%) of Secondary schools?
Provide a succinct answer. 84.04. In the year 1999, what is the difference between the Gross enrolment ratio (%) of Primary schools and Gross enrolment ratio (%) of Tertiary schools?
Your response must be concise. 111.84. In the year 1999, what is the difference between the Gross enrolment ratio (%) of Secondary schools and Gross enrolment ratio (%) of Tertiary schools?
Keep it short and to the point. 27.8. In the year 2000, what is the difference between the Gross enrolment ratio (%) of Pre-primary schools and Gross enrolment ratio (%) of Primary schools?
Make the answer very short. -95.93. In the year 2000, what is the difference between the Gross enrolment ratio (%) of Pre-primary schools and Gross enrolment ratio (%) of Secondary schools?
Your answer should be compact. -14.36. In the year 2000, what is the difference between the Gross enrolment ratio (%) of Pre-primary schools and Gross enrolment ratio (%) of Tertiary schools?
Provide a short and direct response. 11.55. In the year 2000, what is the difference between the Gross enrolment ratio (%) in Primary schools and Gross enrolment ratio (%) in Secondary schools?
Your answer should be compact. 81.57. In the year 2000, what is the difference between the Gross enrolment ratio (%) in Primary schools and Gross enrolment ratio (%) in Tertiary schools?
Keep it short and to the point. 107.48. In the year 2000, what is the difference between the Gross enrolment ratio (%) of Secondary schools and Gross enrolment ratio (%) of Tertiary schools?
Give a very brief answer. 25.91. In the year 2001, what is the difference between the Gross enrolment ratio (%) of Pre-primary schools and Gross enrolment ratio (%) of Primary schools?
Your answer should be very brief. -97.01. In the year 2001, what is the difference between the Gross enrolment ratio (%) in Pre-primary schools and Gross enrolment ratio (%) in Secondary schools?
Give a very brief answer. -11.59. In the year 2001, what is the difference between the Gross enrolment ratio (%) in Pre-primary schools and Gross enrolment ratio (%) in Tertiary schools?
Your response must be concise. 12.78. In the year 2001, what is the difference between the Gross enrolment ratio (%) in Primary schools and Gross enrolment ratio (%) in Secondary schools?
Provide a succinct answer. 85.42. In the year 2001, what is the difference between the Gross enrolment ratio (%) in Primary schools and Gross enrolment ratio (%) in Tertiary schools?
Your answer should be very brief. 109.79. In the year 2001, what is the difference between the Gross enrolment ratio (%) of Secondary schools and Gross enrolment ratio (%) of Tertiary schools?
Your answer should be very brief. 24.36. In the year 2002, what is the difference between the Gross enrolment ratio (%) in Pre-primary schools and Gross enrolment ratio (%) in Primary schools?
Provide a short and direct response. -94.73. In the year 2002, what is the difference between the Gross enrolment ratio (%) in Pre-primary schools and Gross enrolment ratio (%) in Secondary schools?
Your answer should be very brief. -7. In the year 2002, what is the difference between the Gross enrolment ratio (%) in Pre-primary schools and Gross enrolment ratio (%) in Tertiary schools?
Offer a terse response. 14.63. In the year 2002, what is the difference between the Gross enrolment ratio (%) in Primary schools and Gross enrolment ratio (%) in Secondary schools?
Make the answer very short. 87.73. In the year 2002, what is the difference between the Gross enrolment ratio (%) of Primary schools and Gross enrolment ratio (%) of Tertiary schools?
Offer a very short reply. 109.36. In the year 2002, what is the difference between the Gross enrolment ratio (%) of Secondary schools and Gross enrolment ratio (%) of Tertiary schools?
Ensure brevity in your answer.  21.63. In the year 2013, what is the difference between the Gross enrolment ratio (%) of Pre-primary schools and Gross enrolment ratio (%) of Primary schools?
Your answer should be compact. -79.32. In the year 2013, what is the difference between the Gross enrolment ratio (%) of Pre-primary schools and Gross enrolment ratio (%) of Secondary schools?
Provide a short and direct response. 11.59. In the year 2013, what is the difference between the Gross enrolment ratio (%) of Pre-primary schools and Gross enrolment ratio (%) of Tertiary schools?
Your response must be concise. 32.78. In the year 2013, what is the difference between the Gross enrolment ratio (%) in Primary schools and Gross enrolment ratio (%) in Secondary schools?
Your answer should be compact. 90.91. In the year 2013, what is the difference between the Gross enrolment ratio (%) in Primary schools and Gross enrolment ratio (%) in Tertiary schools?
Offer a very short reply. 112.1. In the year 2013, what is the difference between the Gross enrolment ratio (%) in Secondary schools and Gross enrolment ratio (%) in Tertiary schools?
Provide a short and direct response. 21.19. What is the ratio of the Gross enrolment ratio (%) of Pre-primary schools in 1996 to that in 1998?
Your answer should be very brief. 0.89. What is the ratio of the Gross enrolment ratio (%) of Primary schools in 1996 to that in 1998?
Provide a short and direct response. 1.01. What is the ratio of the Gross enrolment ratio (%) of Secondary schools in 1996 to that in 1998?
Make the answer very short. 1.01. What is the ratio of the Gross enrolment ratio (%) of Pre-primary schools in 1996 to that in 1999?
Provide a succinct answer. 0.83. What is the ratio of the Gross enrolment ratio (%) in Primary schools in 1996 to that in 1999?
Offer a very short reply. 1.1. What is the ratio of the Gross enrolment ratio (%) of Secondary schools in 1996 to that in 1999?
Your answer should be very brief. 1.06. What is the ratio of the Gross enrolment ratio (%) of Tertiary schools in 1996 to that in 1999?
Your response must be concise. 1.13. What is the ratio of the Gross enrolment ratio (%) in Pre-primary schools in 1996 to that in 2000?
Keep it short and to the point. 0.74. What is the ratio of the Gross enrolment ratio (%) in Primary schools in 1996 to that in 2000?
Ensure brevity in your answer.  1.13. What is the ratio of the Gross enrolment ratio (%) in Secondary schools in 1996 to that in 2000?
Ensure brevity in your answer.  1.11. What is the ratio of the Gross enrolment ratio (%) of Tertiary schools in 1996 to that in 2000?
Offer a terse response. 1. What is the ratio of the Gross enrolment ratio (%) in Pre-primary schools in 1996 to that in 2001?
Make the answer very short. 0.68. What is the ratio of the Gross enrolment ratio (%) in Primary schools in 1996 to that in 2001?
Keep it short and to the point. 1.11. What is the ratio of the Gross enrolment ratio (%) in Secondary schools in 1996 to that in 2001?
Offer a very short reply. 1.16. What is the ratio of the Gross enrolment ratio (%) in Tertiary schools in 1996 to that in 2001?
Ensure brevity in your answer.  0.98. What is the ratio of the Gross enrolment ratio (%) of Pre-primary schools in 1996 to that in 2002?
Offer a terse response. 0.57. What is the ratio of the Gross enrolment ratio (%) of Primary schools in 1996 to that in 2002?
Your response must be concise. 1.1. What is the ratio of the Gross enrolment ratio (%) of Secondary schools in 1996 to that in 2002?
Provide a short and direct response. 1.22. What is the ratio of the Gross enrolment ratio (%) in Tertiary schools in 1996 to that in 2002?
Keep it short and to the point. 0.71. What is the ratio of the Gross enrolment ratio (%) in Pre-primary schools in 1996 to that in 2013?
Make the answer very short. 0.3. What is the ratio of the Gross enrolment ratio (%) of Primary schools in 1996 to that in 2013?
Keep it short and to the point. 1.07. What is the ratio of the Gross enrolment ratio (%) in Secondary schools in 1996 to that in 2013?
Offer a very short reply. 1.21. What is the ratio of the Gross enrolment ratio (%) of Tertiary schools in 1996 to that in 2013?
Provide a short and direct response. 0.65. What is the ratio of the Gross enrolment ratio (%) of Pre-primary schools in 1998 to that in 1999?
Offer a terse response. 0.93. What is the ratio of the Gross enrolment ratio (%) in Primary schools in 1998 to that in 1999?
Keep it short and to the point. 1.08. What is the ratio of the Gross enrolment ratio (%) of Secondary schools in 1998 to that in 1999?
Your answer should be very brief. 1.05. What is the ratio of the Gross enrolment ratio (%) of Tertiary schools in 1998 to that in 1999?
Offer a very short reply. 1.1. What is the ratio of the Gross enrolment ratio (%) of Pre-primary schools in 1998 to that in 2000?
Provide a succinct answer. 0.83. What is the ratio of the Gross enrolment ratio (%) in Primary schools in 1998 to that in 2000?
Offer a terse response. 1.12. What is the ratio of the Gross enrolment ratio (%) of Secondary schools in 1998 to that in 2000?
Offer a terse response. 1.1. What is the ratio of the Gross enrolment ratio (%) of Tertiary schools in 1998 to that in 2000?
Your response must be concise. 0.98. What is the ratio of the Gross enrolment ratio (%) in Pre-primary schools in 1998 to that in 2001?
Offer a terse response. 0.76. What is the ratio of the Gross enrolment ratio (%) of Primary schools in 1998 to that in 2001?
Offer a very short reply. 1.1. What is the ratio of the Gross enrolment ratio (%) in Secondary schools in 1998 to that in 2001?
Keep it short and to the point. 1.16. What is the ratio of the Gross enrolment ratio (%) in Tertiary schools in 1998 to that in 2001?
Provide a short and direct response. 0.95. What is the ratio of the Gross enrolment ratio (%) of Pre-primary schools in 1998 to that in 2002?
Give a very brief answer. 0.64. What is the ratio of the Gross enrolment ratio (%) of Primary schools in 1998 to that in 2002?
Keep it short and to the point. 1.09. What is the ratio of the Gross enrolment ratio (%) in Secondary schools in 1998 to that in 2002?
Ensure brevity in your answer.  1.21. What is the ratio of the Gross enrolment ratio (%) in Tertiary schools in 1998 to that in 2002?
Your answer should be compact. 0.69. What is the ratio of the Gross enrolment ratio (%) in Pre-primary schools in 1998 to that in 2013?
Offer a terse response. 0.33. What is the ratio of the Gross enrolment ratio (%) of Primary schools in 1998 to that in 2013?
Offer a terse response. 1.06. What is the ratio of the Gross enrolment ratio (%) in Secondary schools in 1998 to that in 2013?
Ensure brevity in your answer.  1.21. What is the ratio of the Gross enrolment ratio (%) in Tertiary schools in 1998 to that in 2013?
Ensure brevity in your answer.  0.64. What is the ratio of the Gross enrolment ratio (%) of Pre-primary schools in 1999 to that in 2000?
Give a very brief answer. 0.9. What is the ratio of the Gross enrolment ratio (%) of Primary schools in 1999 to that in 2000?
Provide a succinct answer. 1.04. What is the ratio of the Gross enrolment ratio (%) in Secondary schools in 1999 to that in 2000?
Your answer should be very brief. 1.05. What is the ratio of the Gross enrolment ratio (%) of Tertiary schools in 1999 to that in 2000?
Offer a terse response. 0.89. What is the ratio of the Gross enrolment ratio (%) in Pre-primary schools in 1999 to that in 2001?
Make the answer very short. 0.83. What is the ratio of the Gross enrolment ratio (%) of Primary schools in 1999 to that in 2001?
Your answer should be very brief. 1.01. What is the ratio of the Gross enrolment ratio (%) in Secondary schools in 1999 to that in 2001?
Your response must be concise. 1.1. What is the ratio of the Gross enrolment ratio (%) of Tertiary schools in 1999 to that in 2001?
Offer a terse response. 0.86. What is the ratio of the Gross enrolment ratio (%) in Pre-primary schools in 1999 to that in 2002?
Ensure brevity in your answer.  0.69. What is the ratio of the Gross enrolment ratio (%) in Primary schools in 1999 to that in 2002?
Provide a short and direct response. 1. What is the ratio of the Gross enrolment ratio (%) of Secondary schools in 1999 to that in 2002?
Offer a terse response. 1.15. What is the ratio of the Gross enrolment ratio (%) in Tertiary schools in 1999 to that in 2002?
Make the answer very short. 0.62. What is the ratio of the Gross enrolment ratio (%) of Pre-primary schools in 1999 to that in 2013?
Provide a succinct answer. 0.36. What is the ratio of the Gross enrolment ratio (%) in Primary schools in 1999 to that in 2013?
Offer a terse response. 0.98. What is the ratio of the Gross enrolment ratio (%) in Secondary schools in 1999 to that in 2013?
Your answer should be compact. 1.15. What is the ratio of the Gross enrolment ratio (%) in Tertiary schools in 1999 to that in 2013?
Keep it short and to the point. 0.58. What is the ratio of the Gross enrolment ratio (%) in Pre-primary schools in 2000 to that in 2001?
Offer a terse response. 0.92. What is the ratio of the Gross enrolment ratio (%) of Primary schools in 2000 to that in 2001?
Your answer should be very brief. 0.98. What is the ratio of the Gross enrolment ratio (%) in Secondary schools in 2000 to that in 2001?
Provide a succinct answer. 1.05. What is the ratio of the Gross enrolment ratio (%) of Tertiary schools in 2000 to that in 2001?
Provide a succinct answer. 0.97. What is the ratio of the Gross enrolment ratio (%) in Pre-primary schools in 2000 to that in 2002?
Ensure brevity in your answer.  0.77. What is the ratio of the Gross enrolment ratio (%) in Primary schools in 2000 to that in 2002?
Offer a terse response. 0.97. What is the ratio of the Gross enrolment ratio (%) in Secondary schools in 2000 to that in 2002?
Ensure brevity in your answer.  1.1. What is the ratio of the Gross enrolment ratio (%) of Tertiary schools in 2000 to that in 2002?
Provide a succinct answer. 0.7. What is the ratio of the Gross enrolment ratio (%) of Pre-primary schools in 2000 to that in 2013?
Your response must be concise. 0.4. What is the ratio of the Gross enrolment ratio (%) of Primary schools in 2000 to that in 2013?
Give a very brief answer. 0.94. What is the ratio of the Gross enrolment ratio (%) in Secondary schools in 2000 to that in 2013?
Your answer should be compact. 1.1. What is the ratio of the Gross enrolment ratio (%) in Tertiary schools in 2000 to that in 2013?
Your response must be concise. 0.65. What is the ratio of the Gross enrolment ratio (%) in Pre-primary schools in 2001 to that in 2002?
Your answer should be compact. 0.83. What is the ratio of the Gross enrolment ratio (%) in Primary schools in 2001 to that in 2002?
Provide a short and direct response. 0.99. What is the ratio of the Gross enrolment ratio (%) of Secondary schools in 2001 to that in 2002?
Provide a short and direct response. 1.04. What is the ratio of the Gross enrolment ratio (%) of Tertiary schools in 2001 to that in 2002?
Offer a very short reply. 0.72. What is the ratio of the Gross enrolment ratio (%) of Pre-primary schools in 2001 to that in 2013?
Offer a terse response. 0.43. What is the ratio of the Gross enrolment ratio (%) of Primary schools in 2001 to that in 2013?
Your answer should be very brief. 0.96. What is the ratio of the Gross enrolment ratio (%) in Secondary schools in 2001 to that in 2013?
Offer a terse response. 1.04. What is the ratio of the Gross enrolment ratio (%) in Tertiary schools in 2001 to that in 2013?
Ensure brevity in your answer.  0.67. What is the ratio of the Gross enrolment ratio (%) of Pre-primary schools in 2002 to that in 2013?
Your answer should be very brief. 0.52. What is the ratio of the Gross enrolment ratio (%) in Primary schools in 2002 to that in 2013?
Your response must be concise. 0.97. What is the ratio of the Gross enrolment ratio (%) of Tertiary schools in 2002 to that in 2013?
Make the answer very short. 0.92. What is the difference between the highest and the second highest Gross enrolment ratio (%) of Pre-primary schools?
Provide a succinct answer. 18.61. What is the difference between the highest and the second highest Gross enrolment ratio (%) of Primary schools?
Your answer should be very brief. 1.57. What is the difference between the highest and the second highest Gross enrolment ratio (%) in Secondary schools?
Provide a short and direct response. 0.22. What is the difference between the highest and the second highest Gross enrolment ratio (%) of Tertiary schools?
Keep it short and to the point. 0.47. What is the difference between the highest and the lowest Gross enrolment ratio (%) of Pre-primary schools?
Provide a short and direct response. 27.37. What is the difference between the highest and the lowest Gross enrolment ratio (%) in Primary schools?
Keep it short and to the point. 14.93. What is the difference between the highest and the lowest Gross enrolment ratio (%) in Secondary schools?
Your response must be concise. 5.86. What is the difference between the highest and the lowest Gross enrolment ratio (%) in Tertiary schools?
Offer a very short reply. 2.57. 